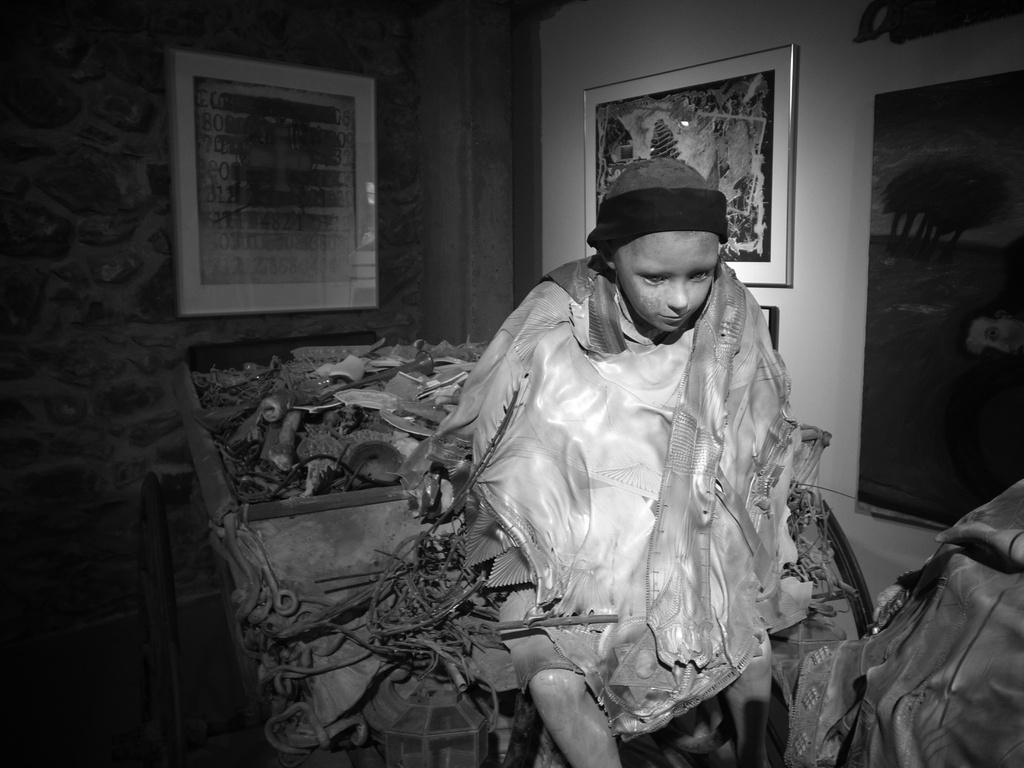Who is the main subject in the image? There is a boy in the image. What is the boy wearing on his head? The boy is wearing a cap. What can be seen on the wall in the image? There are photo frames on the wall in the image. What type of lock is used to secure the unit in the image? There is no lock or unit present in the image; it features a boy wearing a cap and photo frames on the wall. 